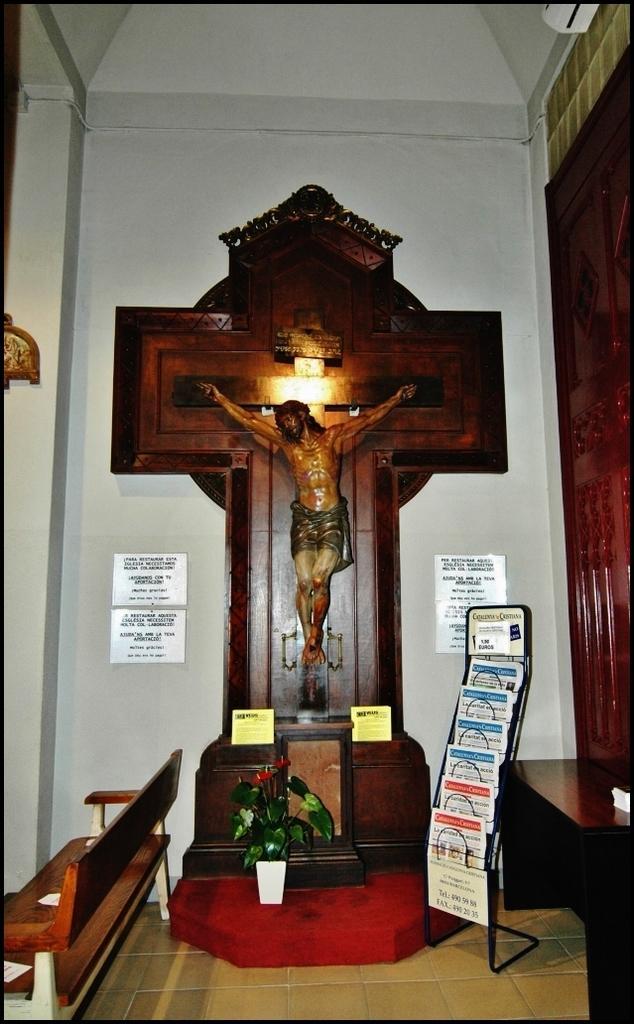Could you give a brief overview of what you see in this image? In this picture I can see a plant, bench, table, books in a stand , a sculpture of a person, boards fixed to the wall. 